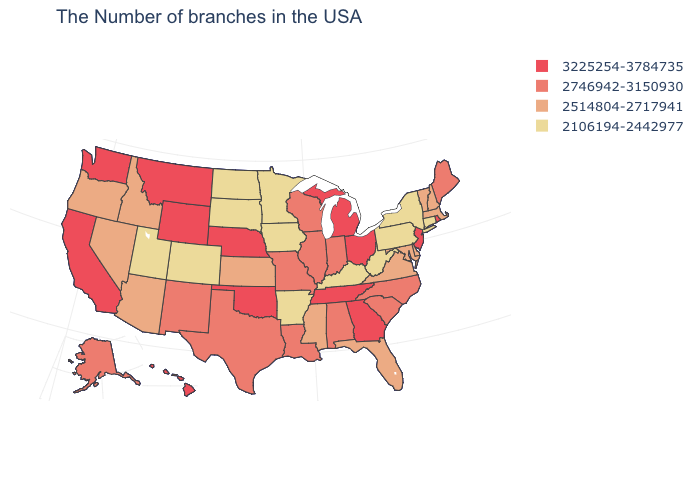Does Ohio have the same value as Massachusetts?
Quick response, please. No. Does the map have missing data?
Short answer required. No. Name the states that have a value in the range 2514804-2717941?
Answer briefly. Massachusetts, New Hampshire, Vermont, Delaware, Maryland, Virginia, Florida, Mississippi, Kansas, Arizona, Idaho, Nevada, Oregon. Name the states that have a value in the range 2746942-3150930?
Write a very short answer. Maine, North Carolina, South Carolina, Indiana, Alabama, Wisconsin, Illinois, Louisiana, Missouri, Texas, New Mexico, Alaska. Does the first symbol in the legend represent the smallest category?
Answer briefly. No. Does the map have missing data?
Concise answer only. No. Among the states that border Utah , which have the highest value?
Give a very brief answer. Wyoming. Does the map have missing data?
Be succinct. No. Does Ohio have the same value as Kansas?
Give a very brief answer. No. Name the states that have a value in the range 3225254-3784735?
Be succinct. Rhode Island, New Jersey, Ohio, Georgia, Michigan, Tennessee, Nebraska, Oklahoma, Wyoming, Montana, California, Washington, Hawaii. What is the value of Indiana?
Keep it brief. 2746942-3150930. Which states hav the highest value in the Northeast?
Short answer required. Rhode Island, New Jersey. What is the highest value in states that border South Dakota?
Write a very short answer. 3225254-3784735. What is the lowest value in the MidWest?
Quick response, please. 2106194-2442977. Which states have the lowest value in the USA?
Short answer required. Connecticut, New York, Pennsylvania, West Virginia, Kentucky, Arkansas, Minnesota, Iowa, South Dakota, North Dakota, Colorado, Utah. 